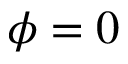Convert formula to latex. <formula><loc_0><loc_0><loc_500><loc_500>\phi = 0</formula> 